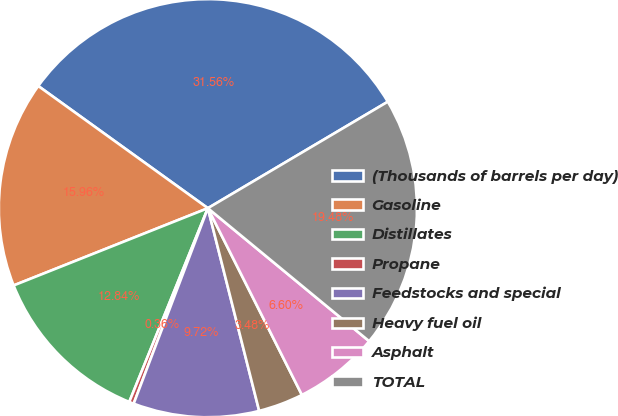Convert chart. <chart><loc_0><loc_0><loc_500><loc_500><pie_chart><fcel>(Thousands of barrels per day)<fcel>Gasoline<fcel>Distillates<fcel>Propane<fcel>Feedstocks and special<fcel>Heavy fuel oil<fcel>Asphalt<fcel>TOTAL<nl><fcel>31.56%<fcel>15.96%<fcel>12.84%<fcel>0.36%<fcel>9.72%<fcel>3.48%<fcel>6.6%<fcel>19.48%<nl></chart> 